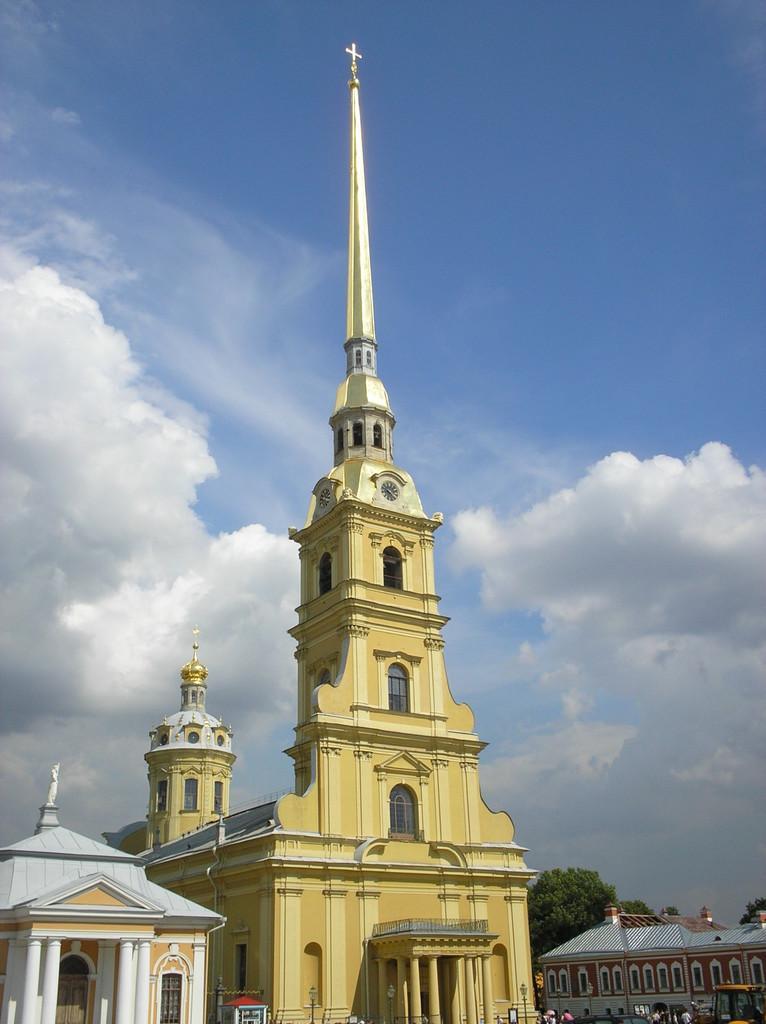Can you describe this image briefly? In the foreground of this image, there are buildings and it seems like there is a church in the middle. In the background, there is the sky and the cloud. 